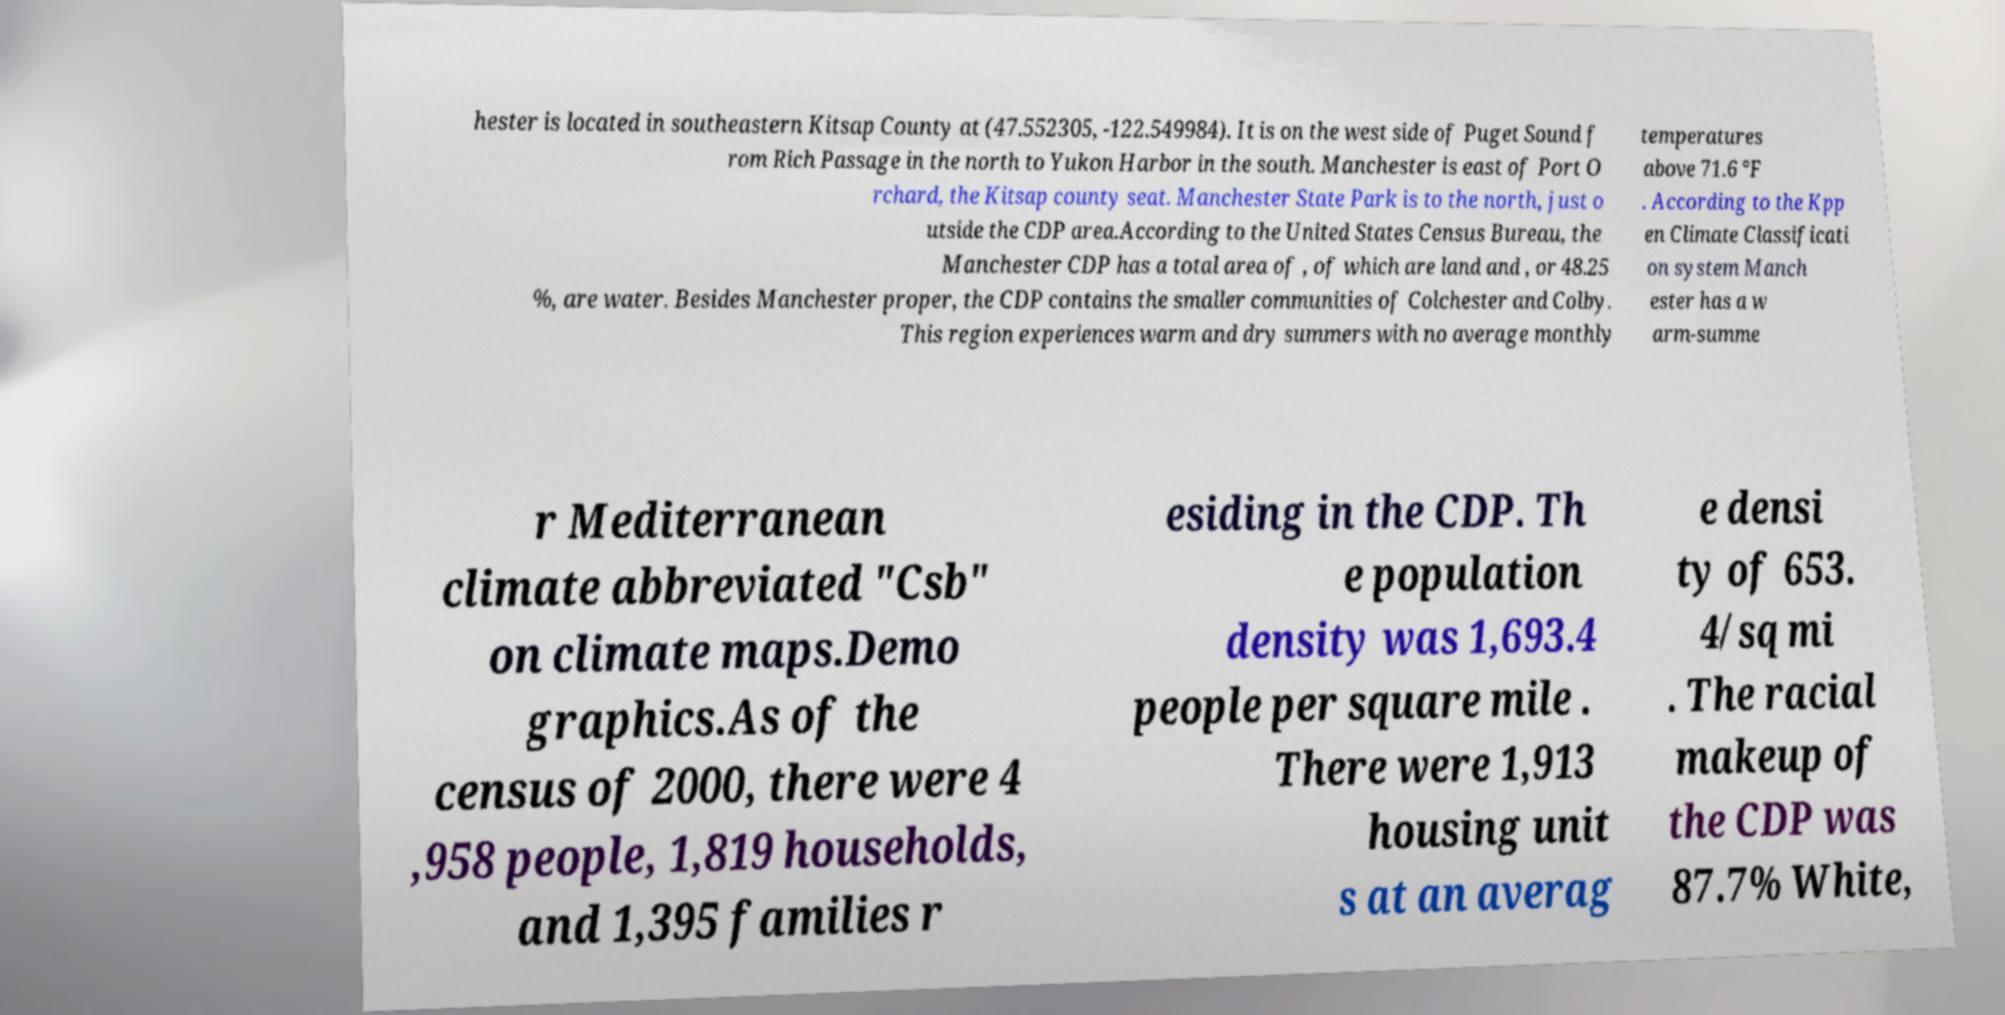I need the written content from this picture converted into text. Can you do that? hester is located in southeastern Kitsap County at (47.552305, -122.549984). It is on the west side of Puget Sound f rom Rich Passage in the north to Yukon Harbor in the south. Manchester is east of Port O rchard, the Kitsap county seat. Manchester State Park is to the north, just o utside the CDP area.According to the United States Census Bureau, the Manchester CDP has a total area of , of which are land and , or 48.25 %, are water. Besides Manchester proper, the CDP contains the smaller communities of Colchester and Colby. This region experiences warm and dry summers with no average monthly temperatures above 71.6 °F . According to the Kpp en Climate Classificati on system Manch ester has a w arm-summe r Mediterranean climate abbreviated "Csb" on climate maps.Demo graphics.As of the census of 2000, there were 4 ,958 people, 1,819 households, and 1,395 families r esiding in the CDP. Th e population density was 1,693.4 people per square mile . There were 1,913 housing unit s at an averag e densi ty of 653. 4/sq mi . The racial makeup of the CDP was 87.7% White, 